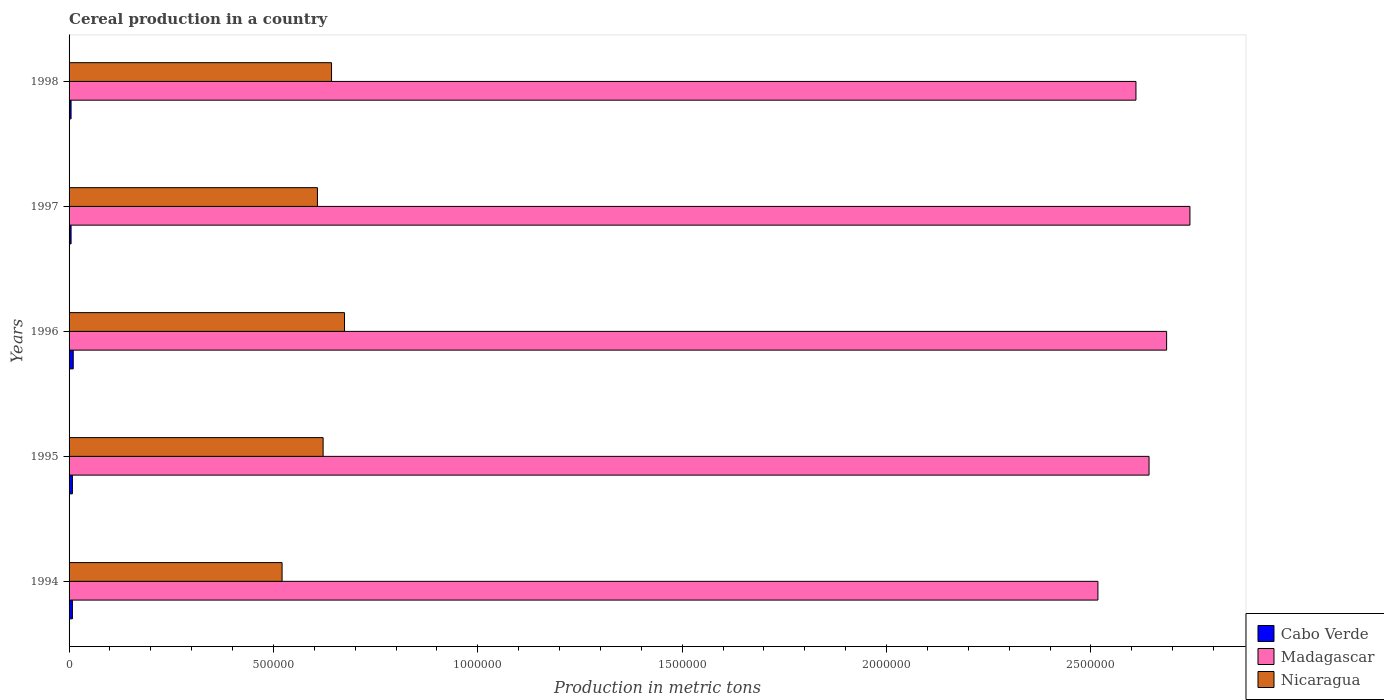How many different coloured bars are there?
Your answer should be very brief. 3. How many groups of bars are there?
Your answer should be very brief. 5. Are the number of bars per tick equal to the number of legend labels?
Ensure brevity in your answer.  Yes. Are the number of bars on each tick of the Y-axis equal?
Provide a short and direct response. Yes. How many bars are there on the 5th tick from the bottom?
Provide a succinct answer. 3. What is the total cereal production in Madagascar in 1998?
Ensure brevity in your answer.  2.61e+06. Across all years, what is the maximum total cereal production in Nicaragua?
Make the answer very short. 6.74e+05. Across all years, what is the minimum total cereal production in Cabo Verde?
Make the answer very short. 4883. In which year was the total cereal production in Cabo Verde maximum?
Your answer should be very brief. 1996. In which year was the total cereal production in Madagascar minimum?
Make the answer very short. 1994. What is the total total cereal production in Nicaragua in the graph?
Your response must be concise. 3.07e+06. What is the difference between the total cereal production in Nicaragua in 1994 and that in 1996?
Provide a succinct answer. -1.53e+05. What is the difference between the total cereal production in Madagascar in 1995 and the total cereal production in Cabo Verde in 1998?
Give a very brief answer. 2.64e+06. What is the average total cereal production in Cabo Verde per year?
Make the answer very short. 7260.4. In the year 1994, what is the difference between the total cereal production in Madagascar and total cereal production in Cabo Verde?
Offer a very short reply. 2.51e+06. What is the ratio of the total cereal production in Cabo Verde in 1997 to that in 1998?
Your response must be concise. 1. Is the total cereal production in Madagascar in 1994 less than that in 1998?
Offer a terse response. Yes. Is the difference between the total cereal production in Madagascar in 1994 and 1998 greater than the difference between the total cereal production in Cabo Verde in 1994 and 1998?
Provide a short and direct response. No. What is the difference between the highest and the second highest total cereal production in Nicaragua?
Give a very brief answer. 3.17e+04. What is the difference between the highest and the lowest total cereal production in Nicaragua?
Your response must be concise. 1.53e+05. Is the sum of the total cereal production in Madagascar in 1996 and 1998 greater than the maximum total cereal production in Nicaragua across all years?
Give a very brief answer. Yes. What does the 3rd bar from the top in 1994 represents?
Keep it short and to the point. Cabo Verde. What does the 3rd bar from the bottom in 1995 represents?
Offer a terse response. Nicaragua. Is it the case that in every year, the sum of the total cereal production in Cabo Verde and total cereal production in Nicaragua is greater than the total cereal production in Madagascar?
Your answer should be compact. No. Are all the bars in the graph horizontal?
Your answer should be very brief. Yes. What is the difference between two consecutive major ticks on the X-axis?
Keep it short and to the point. 5.00e+05. Does the graph contain any zero values?
Your answer should be compact. No. Does the graph contain grids?
Offer a very short reply. No. How are the legend labels stacked?
Your answer should be compact. Vertical. What is the title of the graph?
Provide a succinct answer. Cereal production in a country. What is the label or title of the X-axis?
Keep it short and to the point. Production in metric tons. What is the label or title of the Y-axis?
Your answer should be very brief. Years. What is the Production in metric tons of Cabo Verde in 1994?
Your answer should be compact. 8163. What is the Production in metric tons in Madagascar in 1994?
Your response must be concise. 2.52e+06. What is the Production in metric tons in Nicaragua in 1994?
Your response must be concise. 5.21e+05. What is the Production in metric tons in Cabo Verde in 1995?
Your answer should be compact. 8166. What is the Production in metric tons in Madagascar in 1995?
Give a very brief answer. 2.64e+06. What is the Production in metric tons of Nicaragua in 1995?
Make the answer very short. 6.22e+05. What is the Production in metric tons of Cabo Verde in 1996?
Your answer should be compact. 1.02e+04. What is the Production in metric tons of Madagascar in 1996?
Provide a short and direct response. 2.69e+06. What is the Production in metric tons of Nicaragua in 1996?
Provide a short and direct response. 6.74e+05. What is the Production in metric tons of Cabo Verde in 1997?
Give a very brief answer. 4900. What is the Production in metric tons of Madagascar in 1997?
Make the answer very short. 2.74e+06. What is the Production in metric tons of Nicaragua in 1997?
Provide a short and direct response. 6.08e+05. What is the Production in metric tons of Cabo Verde in 1998?
Provide a short and direct response. 4883. What is the Production in metric tons of Madagascar in 1998?
Give a very brief answer. 2.61e+06. What is the Production in metric tons of Nicaragua in 1998?
Provide a succinct answer. 6.42e+05. Across all years, what is the maximum Production in metric tons in Cabo Verde?
Your answer should be compact. 1.02e+04. Across all years, what is the maximum Production in metric tons in Madagascar?
Keep it short and to the point. 2.74e+06. Across all years, what is the maximum Production in metric tons of Nicaragua?
Ensure brevity in your answer.  6.74e+05. Across all years, what is the minimum Production in metric tons in Cabo Verde?
Provide a short and direct response. 4883. Across all years, what is the minimum Production in metric tons of Madagascar?
Provide a succinct answer. 2.52e+06. Across all years, what is the minimum Production in metric tons in Nicaragua?
Give a very brief answer. 5.21e+05. What is the total Production in metric tons in Cabo Verde in the graph?
Provide a short and direct response. 3.63e+04. What is the total Production in metric tons in Madagascar in the graph?
Your answer should be very brief. 1.32e+07. What is the total Production in metric tons in Nicaragua in the graph?
Your response must be concise. 3.07e+06. What is the difference between the Production in metric tons in Madagascar in 1994 and that in 1995?
Your response must be concise. -1.25e+05. What is the difference between the Production in metric tons of Nicaragua in 1994 and that in 1995?
Provide a succinct answer. -1.00e+05. What is the difference between the Production in metric tons in Cabo Verde in 1994 and that in 1996?
Keep it short and to the point. -2027. What is the difference between the Production in metric tons of Madagascar in 1994 and that in 1996?
Offer a terse response. -1.68e+05. What is the difference between the Production in metric tons of Nicaragua in 1994 and that in 1996?
Keep it short and to the point. -1.53e+05. What is the difference between the Production in metric tons of Cabo Verde in 1994 and that in 1997?
Your answer should be very brief. 3263. What is the difference between the Production in metric tons of Madagascar in 1994 and that in 1997?
Give a very brief answer. -2.25e+05. What is the difference between the Production in metric tons in Nicaragua in 1994 and that in 1997?
Your response must be concise. -8.65e+04. What is the difference between the Production in metric tons of Cabo Verde in 1994 and that in 1998?
Ensure brevity in your answer.  3280. What is the difference between the Production in metric tons of Madagascar in 1994 and that in 1998?
Your answer should be compact. -9.30e+04. What is the difference between the Production in metric tons in Nicaragua in 1994 and that in 1998?
Your answer should be compact. -1.21e+05. What is the difference between the Production in metric tons in Cabo Verde in 1995 and that in 1996?
Offer a terse response. -2024. What is the difference between the Production in metric tons in Madagascar in 1995 and that in 1996?
Provide a succinct answer. -4.30e+04. What is the difference between the Production in metric tons in Nicaragua in 1995 and that in 1996?
Your answer should be compact. -5.23e+04. What is the difference between the Production in metric tons of Cabo Verde in 1995 and that in 1997?
Your answer should be very brief. 3266. What is the difference between the Production in metric tons of Madagascar in 1995 and that in 1997?
Your answer should be compact. -1.00e+05. What is the difference between the Production in metric tons in Nicaragua in 1995 and that in 1997?
Your answer should be very brief. 1.39e+04. What is the difference between the Production in metric tons in Cabo Verde in 1995 and that in 1998?
Provide a succinct answer. 3283. What is the difference between the Production in metric tons in Madagascar in 1995 and that in 1998?
Give a very brief answer. 3.20e+04. What is the difference between the Production in metric tons in Nicaragua in 1995 and that in 1998?
Your answer should be very brief. -2.06e+04. What is the difference between the Production in metric tons in Cabo Verde in 1996 and that in 1997?
Make the answer very short. 5290. What is the difference between the Production in metric tons of Madagascar in 1996 and that in 1997?
Provide a succinct answer. -5.70e+04. What is the difference between the Production in metric tons of Nicaragua in 1996 and that in 1997?
Offer a terse response. 6.63e+04. What is the difference between the Production in metric tons in Cabo Verde in 1996 and that in 1998?
Ensure brevity in your answer.  5307. What is the difference between the Production in metric tons of Madagascar in 1996 and that in 1998?
Give a very brief answer. 7.50e+04. What is the difference between the Production in metric tons in Nicaragua in 1996 and that in 1998?
Give a very brief answer. 3.17e+04. What is the difference between the Production in metric tons in Madagascar in 1997 and that in 1998?
Your answer should be compact. 1.32e+05. What is the difference between the Production in metric tons in Nicaragua in 1997 and that in 1998?
Your answer should be very brief. -3.45e+04. What is the difference between the Production in metric tons of Cabo Verde in 1994 and the Production in metric tons of Madagascar in 1995?
Keep it short and to the point. -2.63e+06. What is the difference between the Production in metric tons in Cabo Verde in 1994 and the Production in metric tons in Nicaragua in 1995?
Keep it short and to the point. -6.13e+05. What is the difference between the Production in metric tons of Madagascar in 1994 and the Production in metric tons of Nicaragua in 1995?
Your answer should be compact. 1.90e+06. What is the difference between the Production in metric tons of Cabo Verde in 1994 and the Production in metric tons of Madagascar in 1996?
Your response must be concise. -2.68e+06. What is the difference between the Production in metric tons of Cabo Verde in 1994 and the Production in metric tons of Nicaragua in 1996?
Your response must be concise. -6.66e+05. What is the difference between the Production in metric tons in Madagascar in 1994 and the Production in metric tons in Nicaragua in 1996?
Give a very brief answer. 1.84e+06. What is the difference between the Production in metric tons of Cabo Verde in 1994 and the Production in metric tons of Madagascar in 1997?
Your response must be concise. -2.73e+06. What is the difference between the Production in metric tons of Cabo Verde in 1994 and the Production in metric tons of Nicaragua in 1997?
Offer a very short reply. -5.99e+05. What is the difference between the Production in metric tons of Madagascar in 1994 and the Production in metric tons of Nicaragua in 1997?
Provide a short and direct response. 1.91e+06. What is the difference between the Production in metric tons in Cabo Verde in 1994 and the Production in metric tons in Madagascar in 1998?
Ensure brevity in your answer.  -2.60e+06. What is the difference between the Production in metric tons of Cabo Verde in 1994 and the Production in metric tons of Nicaragua in 1998?
Keep it short and to the point. -6.34e+05. What is the difference between the Production in metric tons in Madagascar in 1994 and the Production in metric tons in Nicaragua in 1998?
Ensure brevity in your answer.  1.87e+06. What is the difference between the Production in metric tons of Cabo Verde in 1995 and the Production in metric tons of Madagascar in 1996?
Give a very brief answer. -2.68e+06. What is the difference between the Production in metric tons of Cabo Verde in 1995 and the Production in metric tons of Nicaragua in 1996?
Keep it short and to the point. -6.66e+05. What is the difference between the Production in metric tons of Madagascar in 1995 and the Production in metric tons of Nicaragua in 1996?
Ensure brevity in your answer.  1.97e+06. What is the difference between the Production in metric tons in Cabo Verde in 1995 and the Production in metric tons in Madagascar in 1997?
Your response must be concise. -2.73e+06. What is the difference between the Production in metric tons in Cabo Verde in 1995 and the Production in metric tons in Nicaragua in 1997?
Offer a very short reply. -5.99e+05. What is the difference between the Production in metric tons of Madagascar in 1995 and the Production in metric tons of Nicaragua in 1997?
Your answer should be very brief. 2.03e+06. What is the difference between the Production in metric tons in Cabo Verde in 1995 and the Production in metric tons in Madagascar in 1998?
Provide a succinct answer. -2.60e+06. What is the difference between the Production in metric tons in Cabo Verde in 1995 and the Production in metric tons in Nicaragua in 1998?
Provide a succinct answer. -6.34e+05. What is the difference between the Production in metric tons of Madagascar in 1995 and the Production in metric tons of Nicaragua in 1998?
Offer a very short reply. 2.00e+06. What is the difference between the Production in metric tons of Cabo Verde in 1996 and the Production in metric tons of Madagascar in 1997?
Provide a succinct answer. -2.73e+06. What is the difference between the Production in metric tons in Cabo Verde in 1996 and the Production in metric tons in Nicaragua in 1997?
Ensure brevity in your answer.  -5.97e+05. What is the difference between the Production in metric tons in Madagascar in 1996 and the Production in metric tons in Nicaragua in 1997?
Offer a very short reply. 2.08e+06. What is the difference between the Production in metric tons of Cabo Verde in 1996 and the Production in metric tons of Madagascar in 1998?
Ensure brevity in your answer.  -2.60e+06. What is the difference between the Production in metric tons in Cabo Verde in 1996 and the Production in metric tons in Nicaragua in 1998?
Keep it short and to the point. -6.32e+05. What is the difference between the Production in metric tons of Madagascar in 1996 and the Production in metric tons of Nicaragua in 1998?
Offer a terse response. 2.04e+06. What is the difference between the Production in metric tons of Cabo Verde in 1997 and the Production in metric tons of Madagascar in 1998?
Your answer should be compact. -2.61e+06. What is the difference between the Production in metric tons of Cabo Verde in 1997 and the Production in metric tons of Nicaragua in 1998?
Your answer should be compact. -6.37e+05. What is the difference between the Production in metric tons in Madagascar in 1997 and the Production in metric tons in Nicaragua in 1998?
Your response must be concise. 2.10e+06. What is the average Production in metric tons of Cabo Verde per year?
Your response must be concise. 7260.4. What is the average Production in metric tons of Madagascar per year?
Your answer should be very brief. 2.64e+06. What is the average Production in metric tons of Nicaragua per year?
Provide a short and direct response. 6.13e+05. In the year 1994, what is the difference between the Production in metric tons in Cabo Verde and Production in metric tons in Madagascar?
Ensure brevity in your answer.  -2.51e+06. In the year 1994, what is the difference between the Production in metric tons of Cabo Verde and Production in metric tons of Nicaragua?
Ensure brevity in your answer.  -5.13e+05. In the year 1994, what is the difference between the Production in metric tons of Madagascar and Production in metric tons of Nicaragua?
Make the answer very short. 2.00e+06. In the year 1995, what is the difference between the Production in metric tons of Cabo Verde and Production in metric tons of Madagascar?
Make the answer very short. -2.63e+06. In the year 1995, what is the difference between the Production in metric tons of Cabo Verde and Production in metric tons of Nicaragua?
Give a very brief answer. -6.13e+05. In the year 1995, what is the difference between the Production in metric tons in Madagascar and Production in metric tons in Nicaragua?
Provide a succinct answer. 2.02e+06. In the year 1996, what is the difference between the Production in metric tons of Cabo Verde and Production in metric tons of Madagascar?
Offer a terse response. -2.67e+06. In the year 1996, what is the difference between the Production in metric tons of Cabo Verde and Production in metric tons of Nicaragua?
Your response must be concise. -6.64e+05. In the year 1996, what is the difference between the Production in metric tons in Madagascar and Production in metric tons in Nicaragua?
Offer a very short reply. 2.01e+06. In the year 1997, what is the difference between the Production in metric tons of Cabo Verde and Production in metric tons of Madagascar?
Provide a short and direct response. -2.74e+06. In the year 1997, what is the difference between the Production in metric tons of Cabo Verde and Production in metric tons of Nicaragua?
Your answer should be very brief. -6.03e+05. In the year 1997, what is the difference between the Production in metric tons of Madagascar and Production in metric tons of Nicaragua?
Provide a succinct answer. 2.13e+06. In the year 1998, what is the difference between the Production in metric tons in Cabo Verde and Production in metric tons in Madagascar?
Your answer should be compact. -2.61e+06. In the year 1998, what is the difference between the Production in metric tons of Cabo Verde and Production in metric tons of Nicaragua?
Make the answer very short. -6.37e+05. In the year 1998, what is the difference between the Production in metric tons of Madagascar and Production in metric tons of Nicaragua?
Make the answer very short. 1.97e+06. What is the ratio of the Production in metric tons in Madagascar in 1994 to that in 1995?
Provide a succinct answer. 0.95. What is the ratio of the Production in metric tons in Nicaragua in 1994 to that in 1995?
Keep it short and to the point. 0.84. What is the ratio of the Production in metric tons of Cabo Verde in 1994 to that in 1996?
Offer a terse response. 0.8. What is the ratio of the Production in metric tons of Madagascar in 1994 to that in 1996?
Ensure brevity in your answer.  0.94. What is the ratio of the Production in metric tons in Nicaragua in 1994 to that in 1996?
Make the answer very short. 0.77. What is the ratio of the Production in metric tons of Cabo Verde in 1994 to that in 1997?
Give a very brief answer. 1.67. What is the ratio of the Production in metric tons in Madagascar in 1994 to that in 1997?
Give a very brief answer. 0.92. What is the ratio of the Production in metric tons in Nicaragua in 1994 to that in 1997?
Give a very brief answer. 0.86. What is the ratio of the Production in metric tons of Cabo Verde in 1994 to that in 1998?
Give a very brief answer. 1.67. What is the ratio of the Production in metric tons in Madagascar in 1994 to that in 1998?
Your answer should be compact. 0.96. What is the ratio of the Production in metric tons in Nicaragua in 1994 to that in 1998?
Make the answer very short. 0.81. What is the ratio of the Production in metric tons in Cabo Verde in 1995 to that in 1996?
Offer a very short reply. 0.8. What is the ratio of the Production in metric tons in Madagascar in 1995 to that in 1996?
Ensure brevity in your answer.  0.98. What is the ratio of the Production in metric tons of Nicaragua in 1995 to that in 1996?
Provide a succinct answer. 0.92. What is the ratio of the Production in metric tons in Cabo Verde in 1995 to that in 1997?
Your answer should be very brief. 1.67. What is the ratio of the Production in metric tons of Madagascar in 1995 to that in 1997?
Make the answer very short. 0.96. What is the ratio of the Production in metric tons of Nicaragua in 1995 to that in 1997?
Provide a short and direct response. 1.02. What is the ratio of the Production in metric tons of Cabo Verde in 1995 to that in 1998?
Keep it short and to the point. 1.67. What is the ratio of the Production in metric tons of Madagascar in 1995 to that in 1998?
Your response must be concise. 1.01. What is the ratio of the Production in metric tons in Nicaragua in 1995 to that in 1998?
Make the answer very short. 0.97. What is the ratio of the Production in metric tons in Cabo Verde in 1996 to that in 1997?
Provide a short and direct response. 2.08. What is the ratio of the Production in metric tons of Madagascar in 1996 to that in 1997?
Offer a very short reply. 0.98. What is the ratio of the Production in metric tons of Nicaragua in 1996 to that in 1997?
Offer a terse response. 1.11. What is the ratio of the Production in metric tons in Cabo Verde in 1996 to that in 1998?
Keep it short and to the point. 2.09. What is the ratio of the Production in metric tons in Madagascar in 1996 to that in 1998?
Provide a short and direct response. 1.03. What is the ratio of the Production in metric tons of Nicaragua in 1996 to that in 1998?
Offer a terse response. 1.05. What is the ratio of the Production in metric tons of Cabo Verde in 1997 to that in 1998?
Provide a short and direct response. 1. What is the ratio of the Production in metric tons in Madagascar in 1997 to that in 1998?
Provide a succinct answer. 1.05. What is the ratio of the Production in metric tons in Nicaragua in 1997 to that in 1998?
Provide a succinct answer. 0.95. What is the difference between the highest and the second highest Production in metric tons in Cabo Verde?
Keep it short and to the point. 2024. What is the difference between the highest and the second highest Production in metric tons of Madagascar?
Ensure brevity in your answer.  5.70e+04. What is the difference between the highest and the second highest Production in metric tons in Nicaragua?
Offer a terse response. 3.17e+04. What is the difference between the highest and the lowest Production in metric tons of Cabo Verde?
Offer a very short reply. 5307. What is the difference between the highest and the lowest Production in metric tons in Madagascar?
Make the answer very short. 2.25e+05. What is the difference between the highest and the lowest Production in metric tons in Nicaragua?
Ensure brevity in your answer.  1.53e+05. 